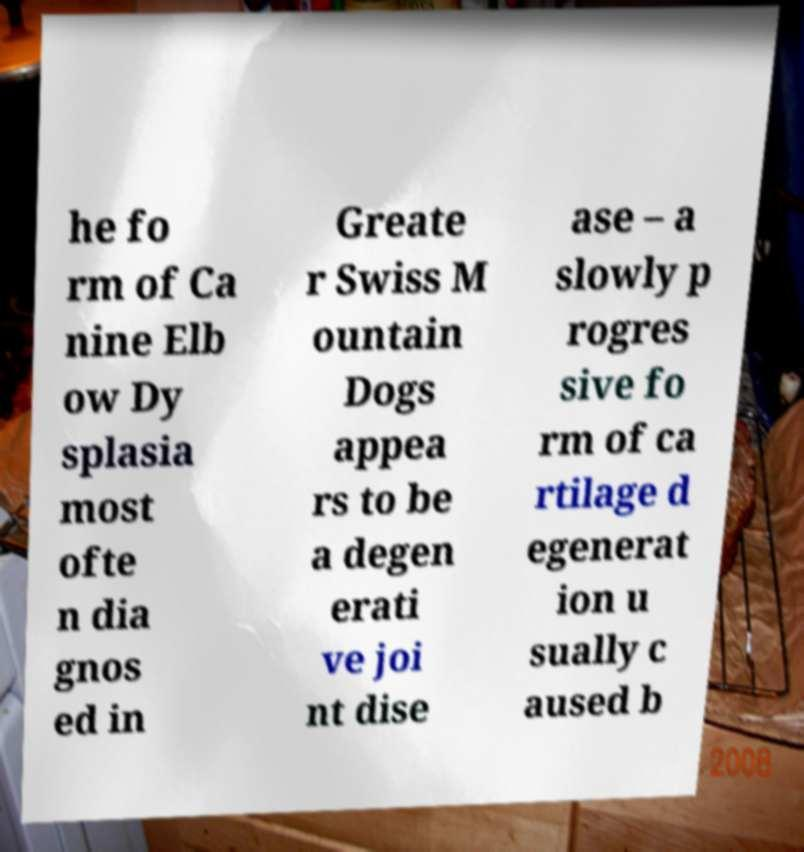What messages or text are displayed in this image? I need them in a readable, typed format. he fo rm of Ca nine Elb ow Dy splasia most ofte n dia gnos ed in Greate r Swiss M ountain Dogs appea rs to be a degen erati ve joi nt dise ase – a slowly p rogres sive fo rm of ca rtilage d egenerat ion u sually c aused b 